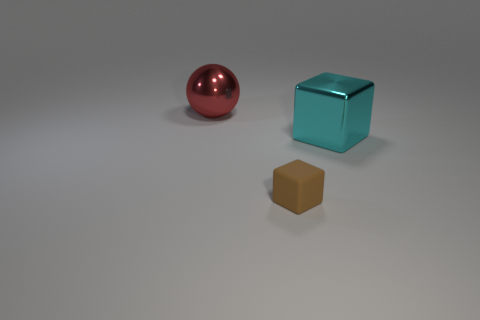Is there a cyan object that is in front of the large object on the left side of the brown matte cube that is to the right of the ball?
Provide a succinct answer. Yes. What number of things are big spheres or cyan things?
Make the answer very short. 2. Does the large cyan thing have the same material as the object behind the cyan cube?
Ensure brevity in your answer.  Yes. Is there anything else of the same color as the tiny thing?
Your response must be concise. No. What number of objects are either objects that are behind the tiny brown object or objects that are left of the big block?
Your answer should be very brief. 3. What shape is the thing that is right of the big red ball and on the left side of the metal cube?
Your response must be concise. Cube. What number of small cubes are in front of the shiny thing on the right side of the brown block?
Keep it short and to the point. 1. Are there any other things that have the same material as the small brown block?
Ensure brevity in your answer.  No. How many things are big metal things that are on the left side of the brown thing or big green metal balls?
Give a very brief answer. 1. What size is the metallic thing to the right of the big red sphere?
Provide a succinct answer. Large. 